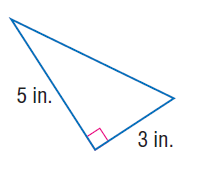Answer the mathemtical geometry problem and directly provide the correct option letter.
Question: Use the Pythagorean Theorem to find the length of the hypotenuse of the right triangle.
Choices: A: 3 B: 4 C: 5 D: \sqrt { 34 } D 